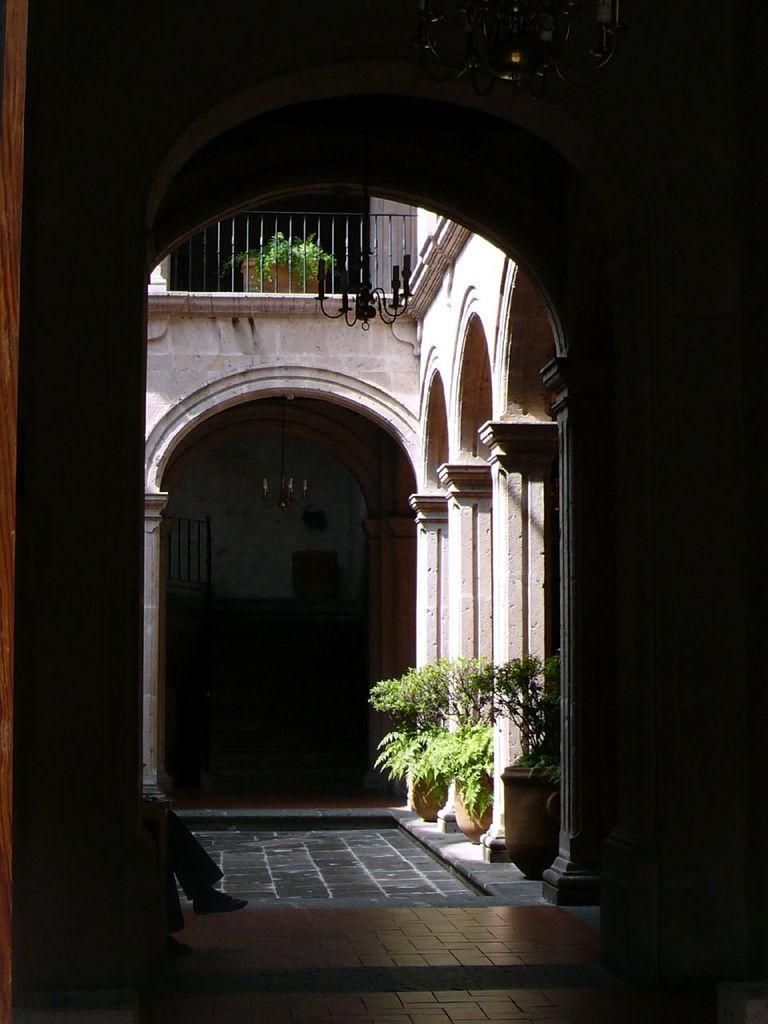What type of location is depicted in the image? The image shows an inside view of a building. Can you describe any people in the image? A person's legs are visible in the image. What other objects or features can be seen on the floor? There are houseplants on the floor in the image. What type of harmony is being played by the umbrella in the image? There is no umbrella present in the image, and therefore no music or harmony can be associated with it. 